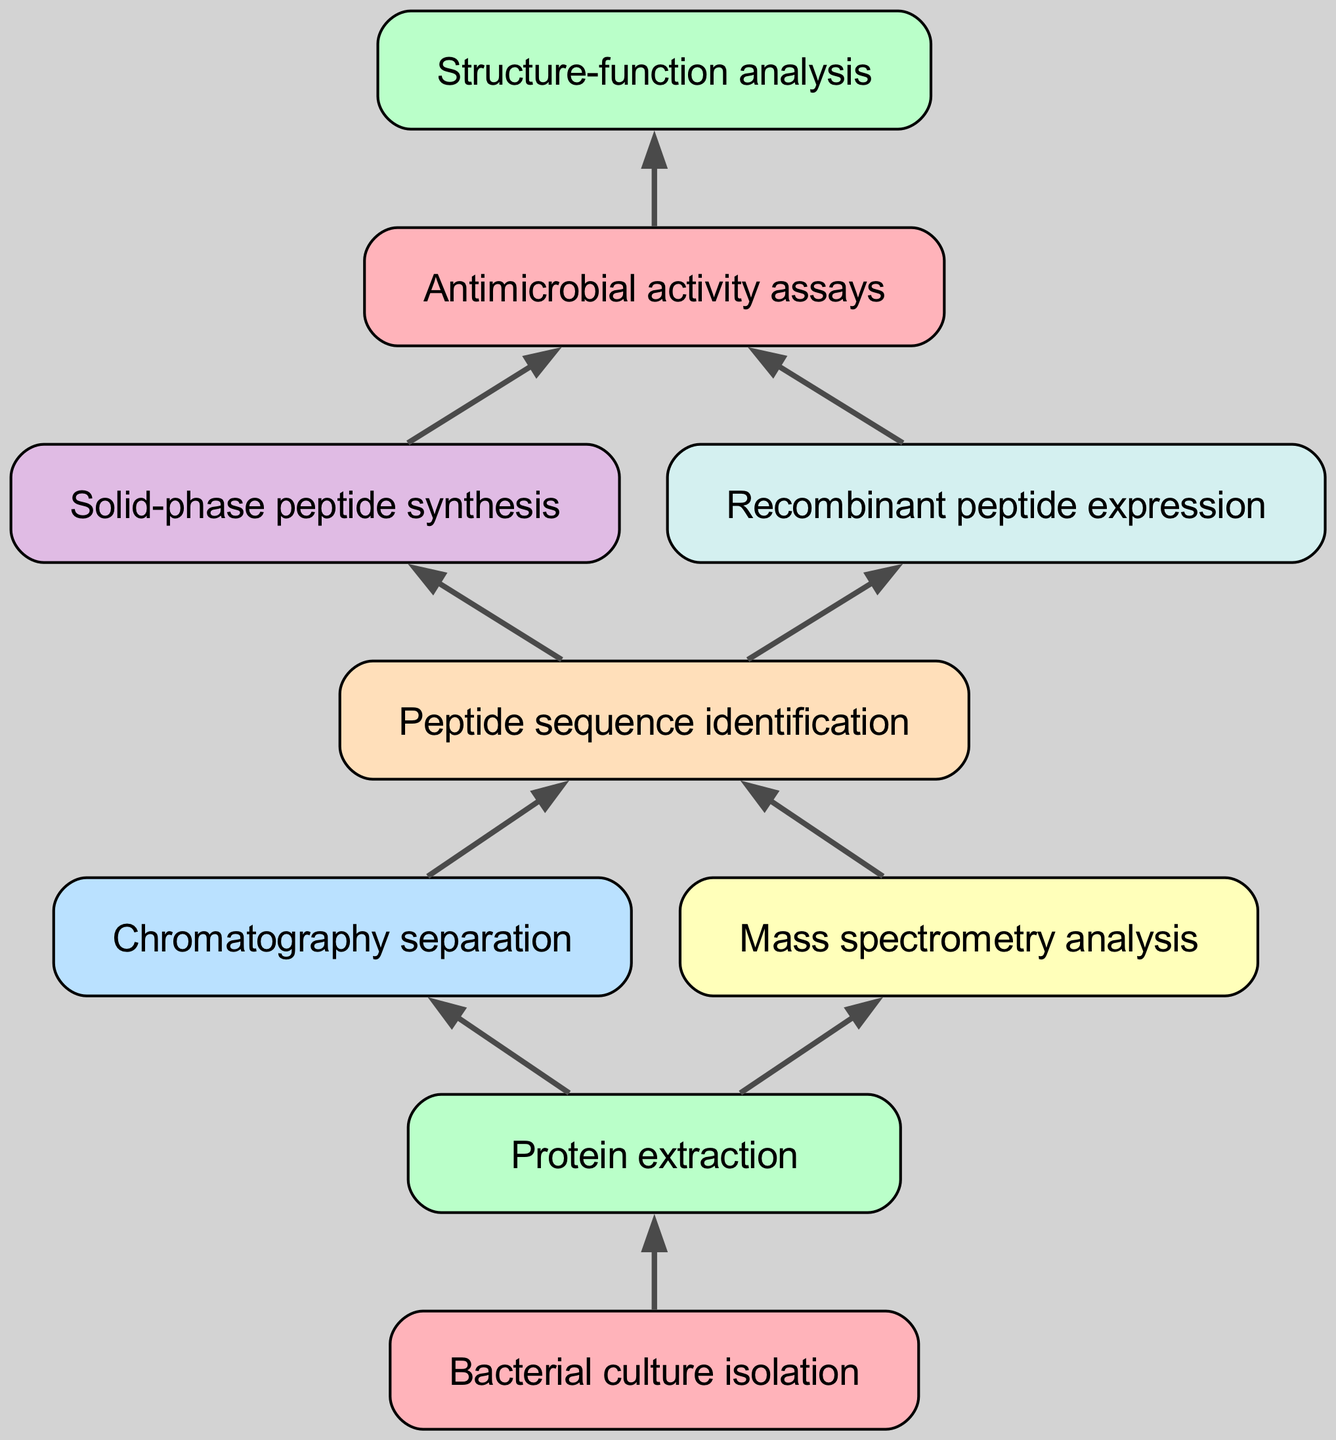What is the first step in the flow chart? The first step is labeled "Bacterial culture isolation," which is at the top of the diagram.
Answer: Bacterial culture isolation How many connections does "Protein extraction" have? "Protein extraction" has two connections leading to "Chromatography separation" and "Mass spectrometry analysis."
Answer: 2 Which step comes after "Peptide sequence identification"? The step that follows "Peptide sequence identification" is "Antimicrobial activity assays," indicating a direct flow from one to the other.
Answer: Antimicrobial activity assays What are the two methods used for peptide synthesis? The diagram shows "Solid-phase peptide synthesis" and "Recombinant peptide expression" as the two methods used for peptide synthesis following "Peptide sequence identification."
Answer: Solid-phase peptide synthesis and Recombinant peptide expression What is the last step in the flow chart? The last step is "Structure-function analysis," which does not have any further connections extending from it.
Answer: Structure-function analysis Which steps are part of the protein extraction process? The steps connected to "Protein extraction" are "Chromatography separation" and "Mass spectrometry analysis," illustrating the methods used during protein extraction.
Answer: Chromatography separation and Mass spectrometry analysis How many total steps are there in the diagram? Counting all the nodes from the beginning to the end, there are nine steps listed sequentially in the diagram.
Answer: 9 What connects "Mass spectrometry analysis" and "Peptide sequence identification"? "Mass spectrometry analysis" connects directly to "Peptide sequence identification," indicating that it is a step contributing to identifying the peptide sequences.
Answer: Peptide sequence identification Which step is the immediate predecessor of "Antimicrobial activity assays"? "Antimicrobial activity assays" is immediately preceded by both "Solid-phase peptide synthesis" and "Recombinant peptide expression," indicating the final synthesis steps before testing.
Answer: Solid-phase peptide synthesis and Recombinant peptide expression 